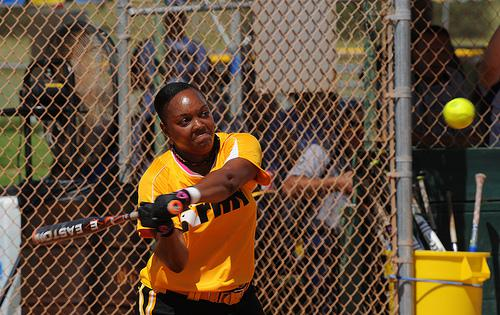Question: who is about to hit a ball with the bat?
Choices:
A. Woman in yellow.
B. Boy in blue.
C. Batter.
D. Girl in red.
Answer with the letter. Answer: A Question: how is the crowd protected from the balls?
Choices:
A. Barricade.
B. Clear plastic wall.
C. Fence.
D. Netting.
Answer with the letter. Answer: C Question: what arm is extended straight on the batter?
Choices:
A. Right.
B. Left.
C. Neither.
D. Both.
Answer with the letter. Answer: B Question: what does the girl have around her waist?
Choices:
A. Beads.
B. Sash.
C. Belt.
D. Tattoo.
Answer with the letter. Answer: C Question: why does the girl have gloves on?
Choices:
A. Keep hands warm.
B. To grip better.
C. Have grip on bat.
D. Protection.
Answer with the letter. Answer: C Question: what type of ball is the girl hitting with the bat?
Choices:
A. Tennis ball.
B. Softball.
C. Baseball.
D. Plastic ball.
Answer with the letter. Answer: A Question: where was this picture taken?
Choices:
A. At the beach.
B. During church.
C. In the winter.
D. Baseball game.
Answer with the letter. Answer: D 